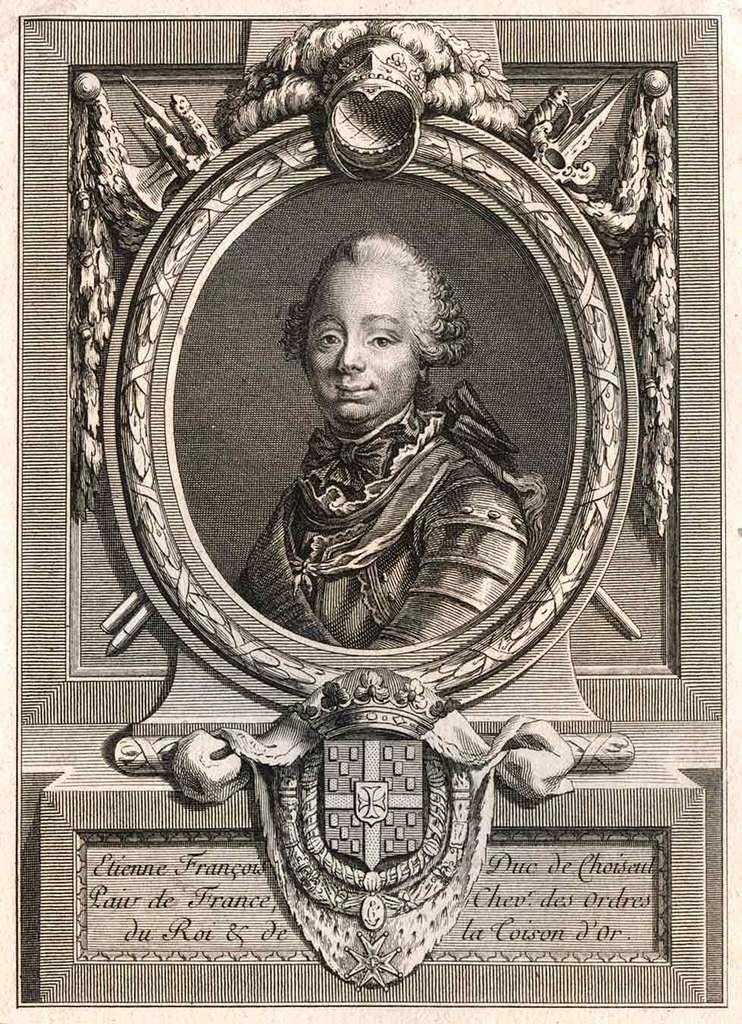Provide a one-sentence caption for the provided image. An artist's drawing of a portrait of Etienne Francois. 